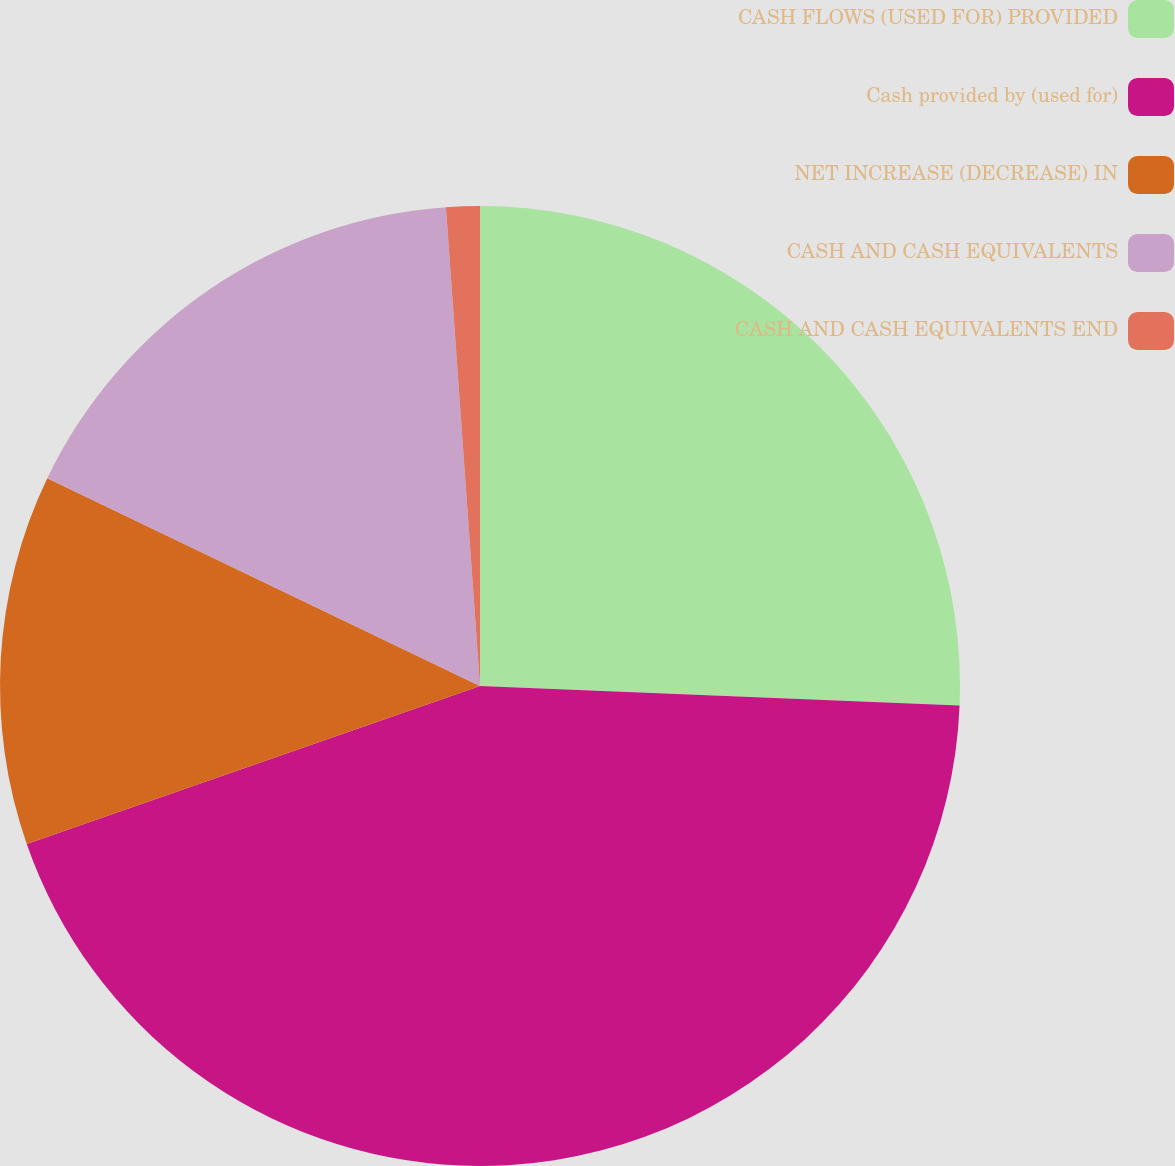Convert chart. <chart><loc_0><loc_0><loc_500><loc_500><pie_chart><fcel>CASH FLOWS (USED FOR) PROVIDED<fcel>Cash provided by (used for)<fcel>NET INCREASE (DECREASE) IN<fcel>CASH AND CASH EQUIVALENTS<fcel>CASH AND CASH EQUIVALENTS END<nl><fcel>25.65%<fcel>44.02%<fcel>12.46%<fcel>16.75%<fcel>1.13%<nl></chart> 